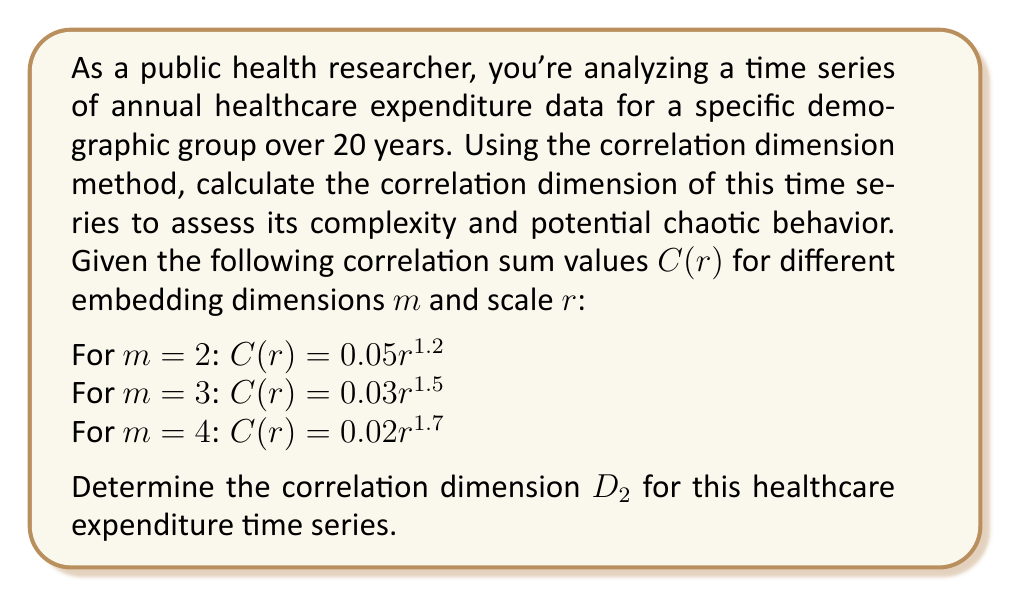Show me your answer to this math problem. To calculate the correlation dimension D_2, we'll follow these steps:

1) The correlation sum C(r) is related to the scale r by the power law:
   
   $$C(r) \propto r^{D_2}$$

2) Taking the logarithm of both sides:
   
   $$\log(C(r)) \propto D_2 \log(r)$$

3) The correlation dimension D_2 is the slope of the log(C(r)) vs log(r) plot in the limit of small r and large m.

4) For each embedding dimension m, we can identify D_2 as the exponent in the given equations:

   For m = 2: D_2 ≈ 1.2
   For m = 3: D_2 ≈ 1.5
   For m = 4: D_2 ≈ 1.7

5) We observe that D_2 increases with m and appears to be converging.

6) The true correlation dimension is the limit of D_2 as m approaches infinity. In practice, we estimate it by looking at where D_2 converges for increasing m.

7) Based on the given data, D_2 seems to be converging towards a value between 1.7 and 2.0.

8) Given the limited data, we can estimate D_2 ≈ 1.7, which is the value for the highest given embedding dimension (m = 4).

This non-integer dimension suggests that the healthcare expenditure time series exhibits fractal characteristics and potentially chaotic behavior, indicating a complex system with multiple influencing factors.
Answer: D_2 ≈ 1.7 